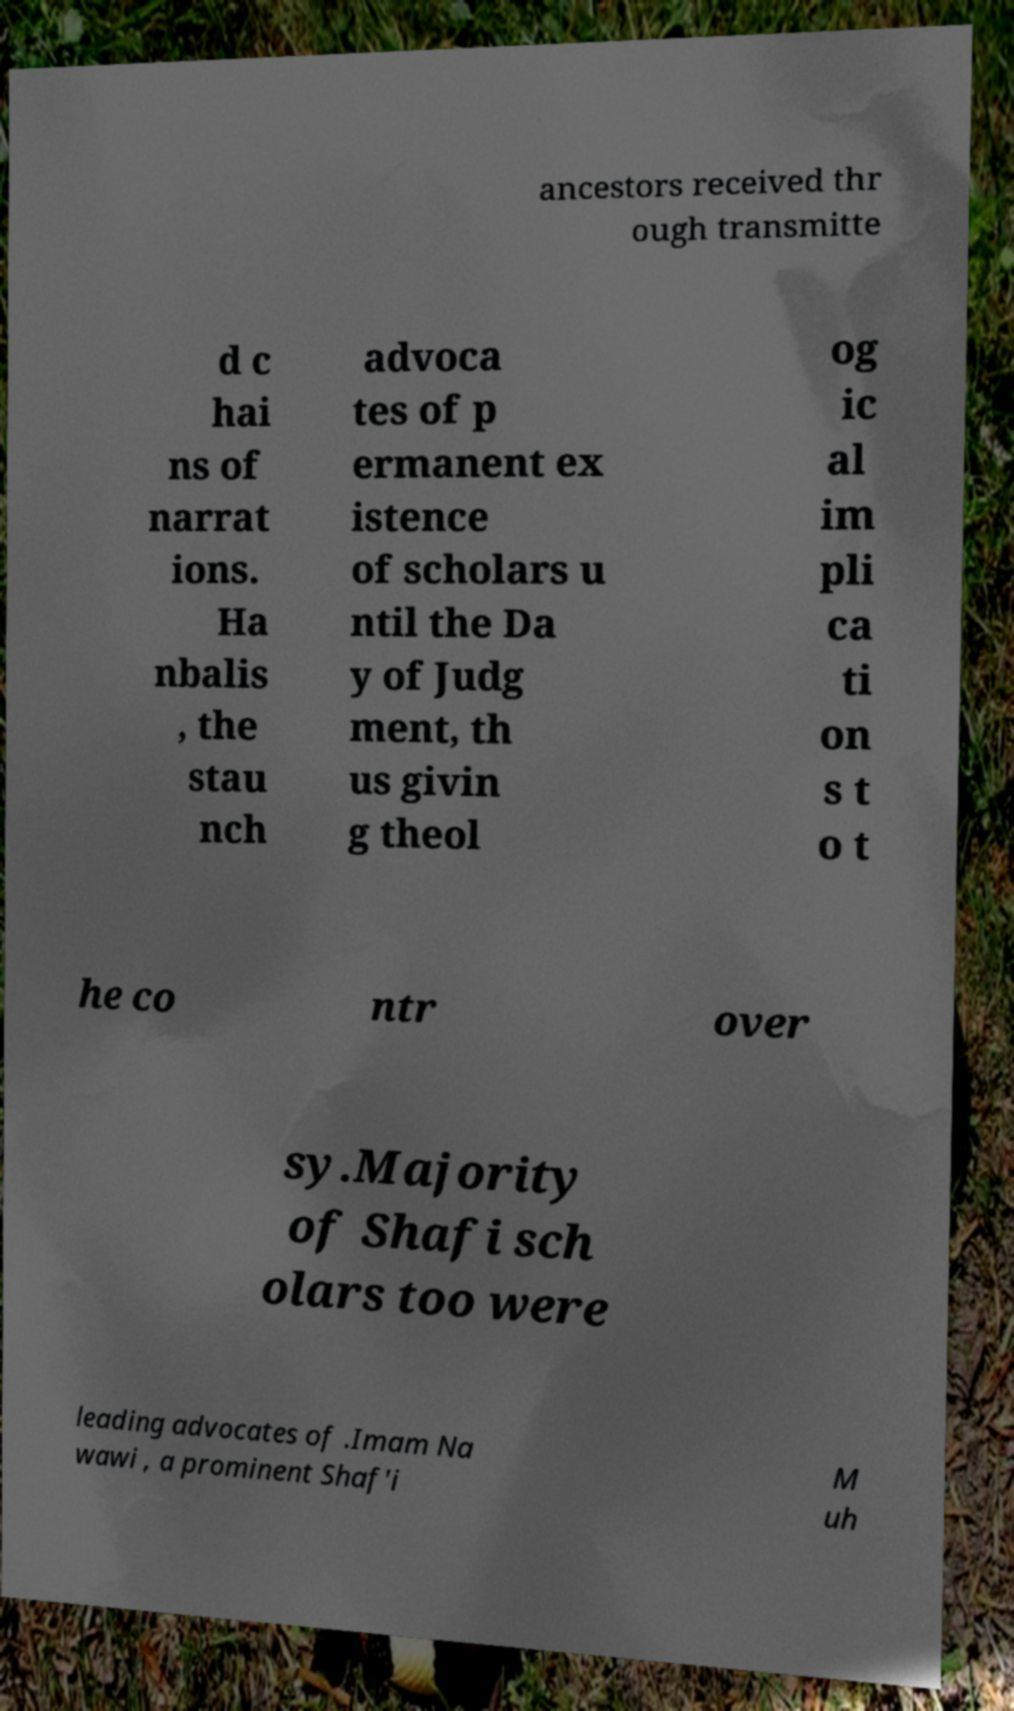I need the written content from this picture converted into text. Can you do that? ancestors received thr ough transmitte d c hai ns of narrat ions. Ha nbalis , the stau nch advoca tes of p ermanent ex istence of scholars u ntil the Da y of Judg ment, th us givin g theol og ic al im pli ca ti on s t o t he co ntr over sy.Majority of Shafi sch olars too were leading advocates of .Imam Na wawi , a prominent Shaf'i M uh 